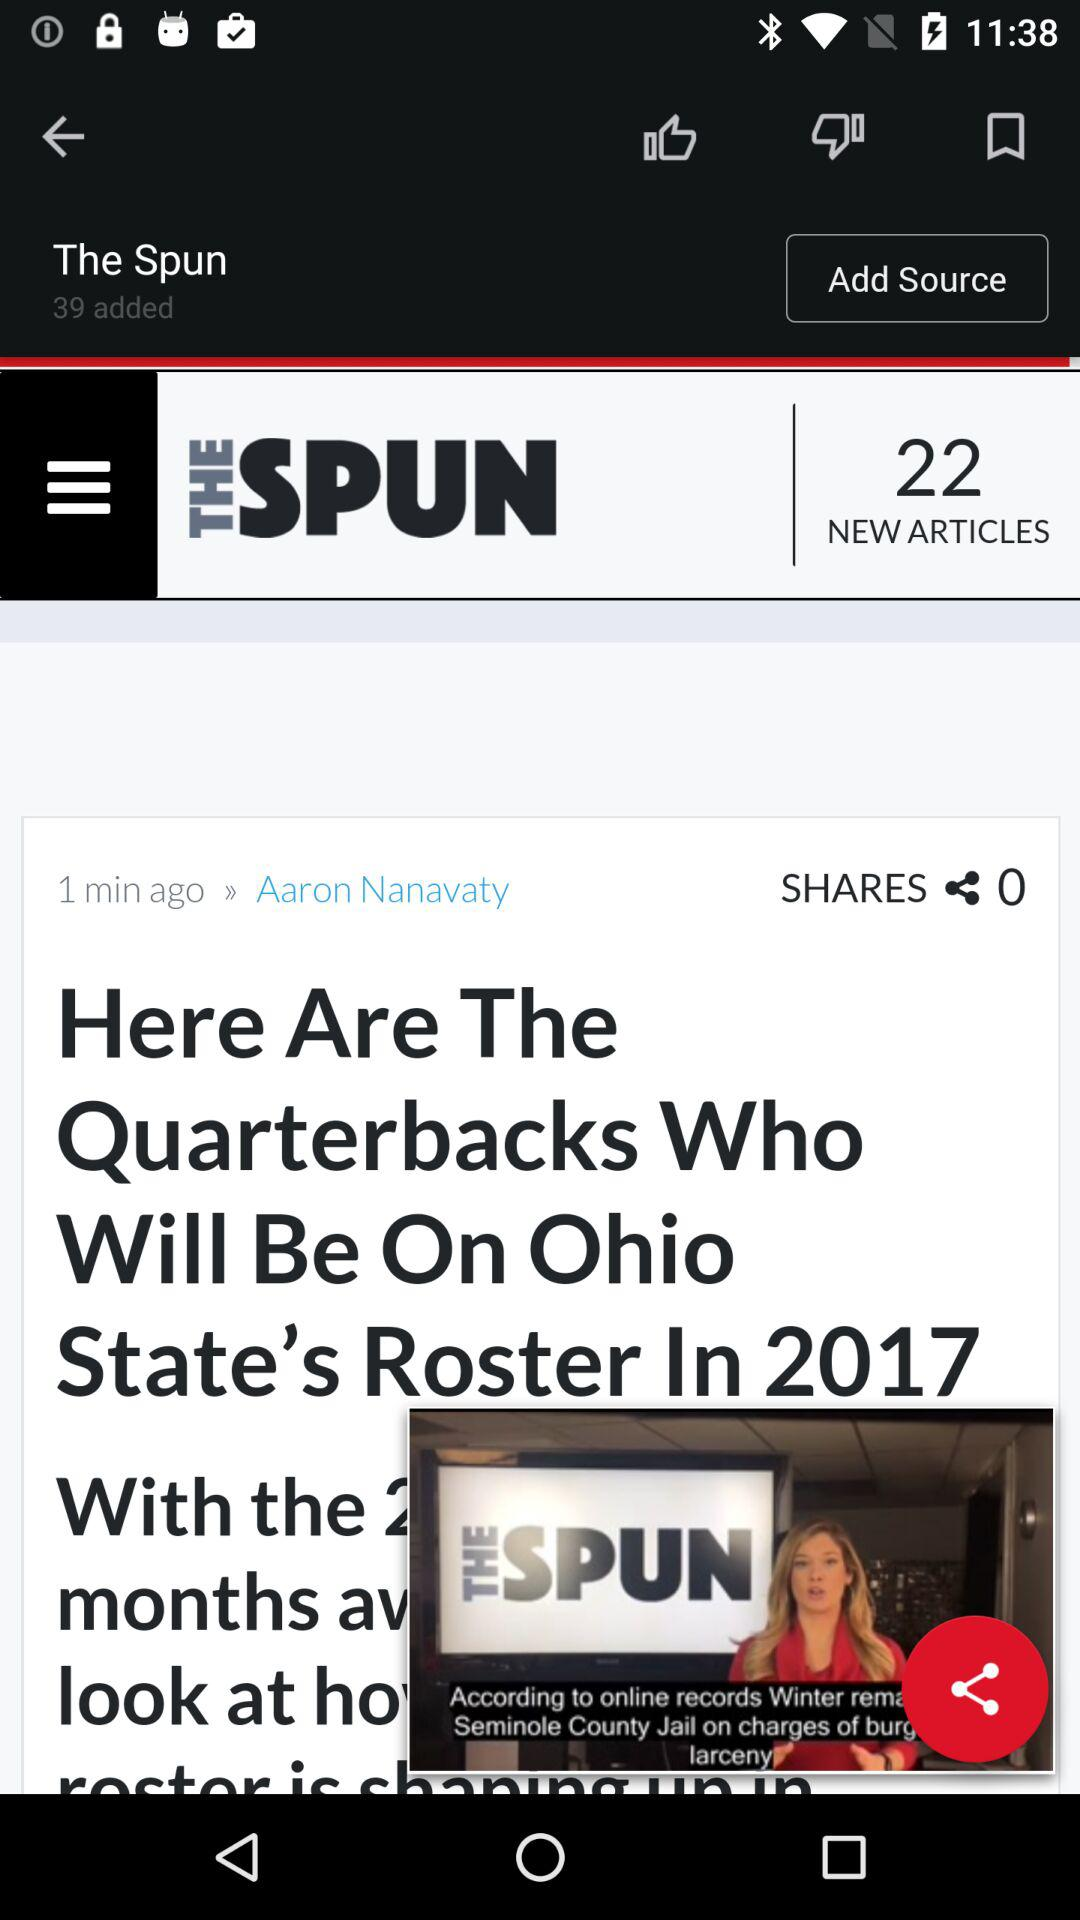What is the total number of sources added? The total number of sources added is 39. 